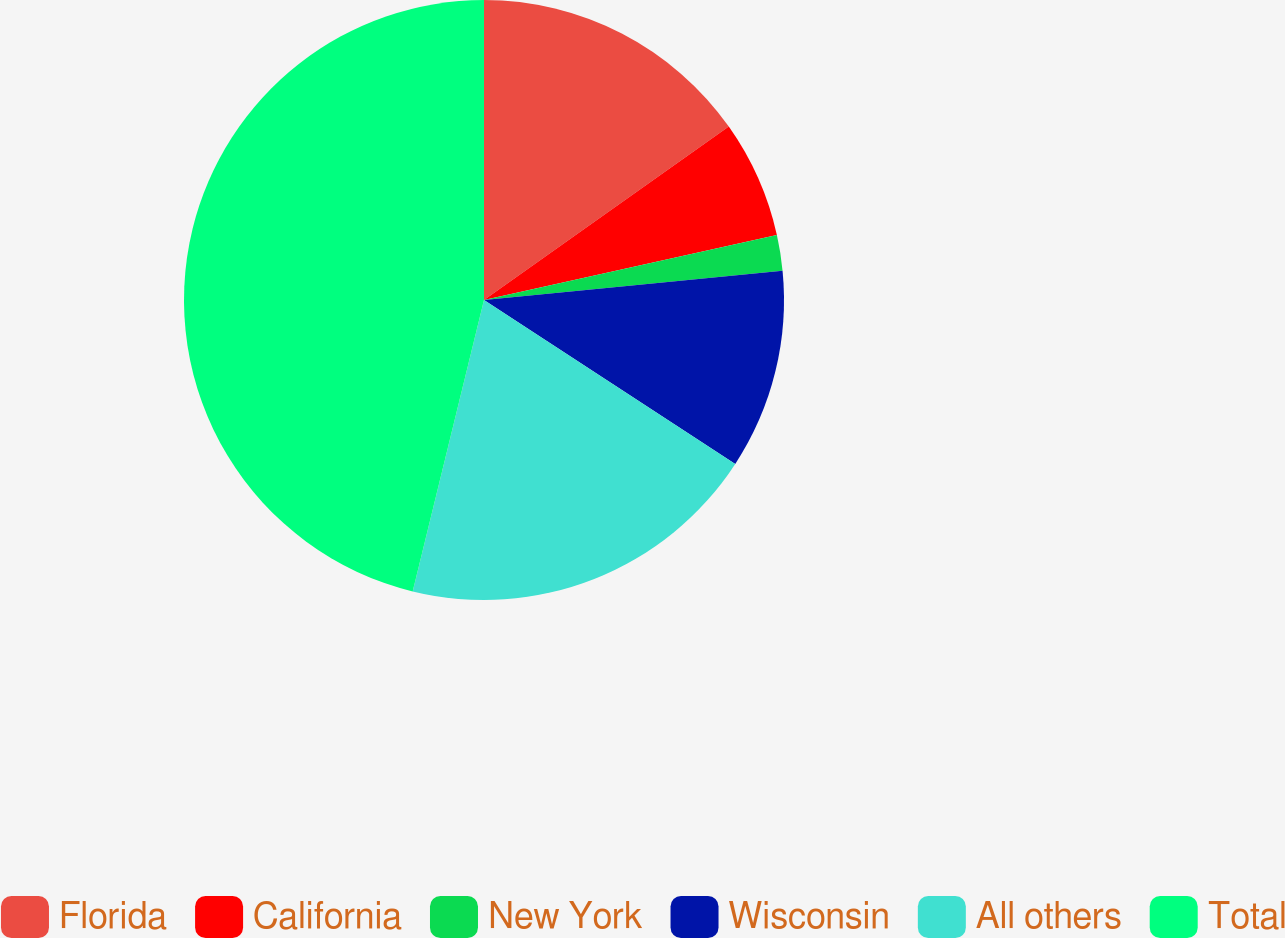Convert chart to OTSL. <chart><loc_0><loc_0><loc_500><loc_500><pie_chart><fcel>Florida<fcel>California<fcel>New York<fcel>Wisconsin<fcel>All others<fcel>Total<nl><fcel>15.19%<fcel>6.34%<fcel>1.91%<fcel>10.76%<fcel>19.62%<fcel>46.18%<nl></chart> 